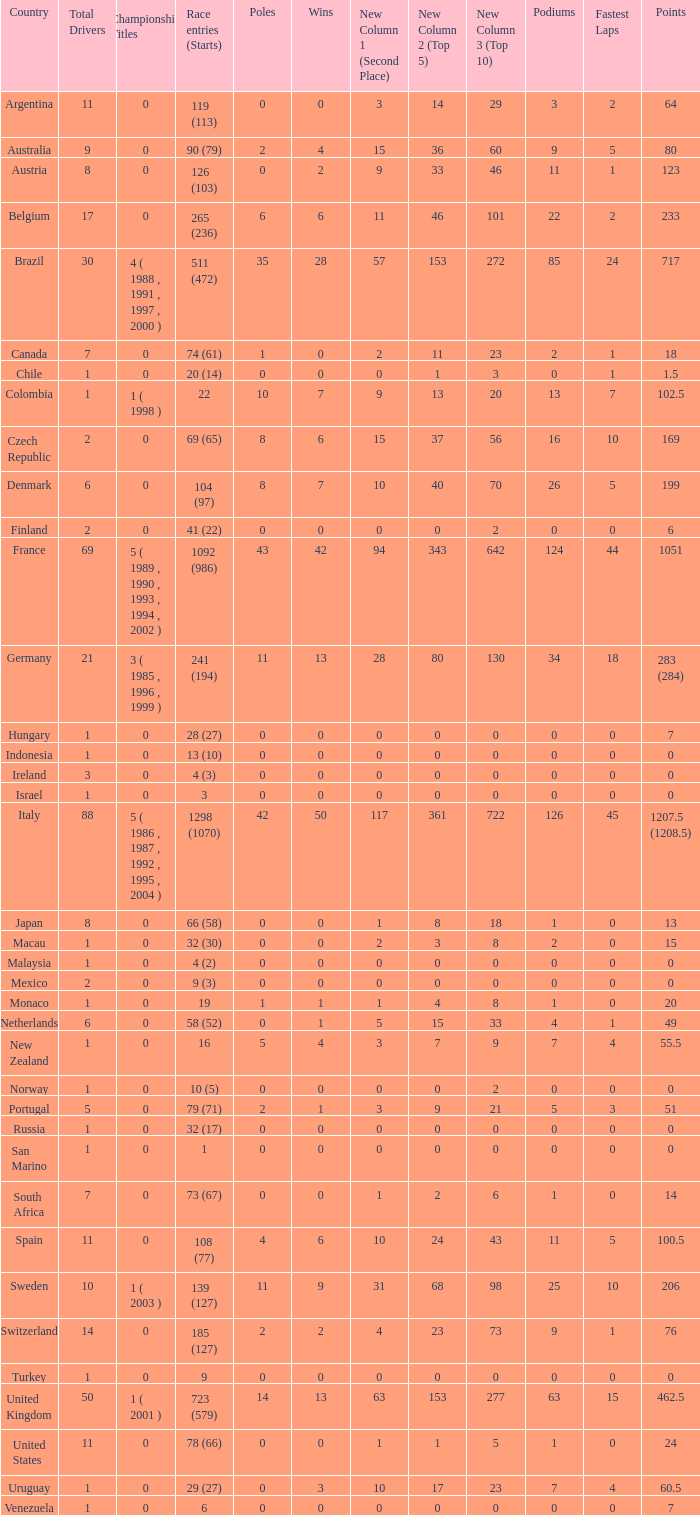How many titles for the nation with less than 3 fastest laps and 22 podiums? 0.0. 